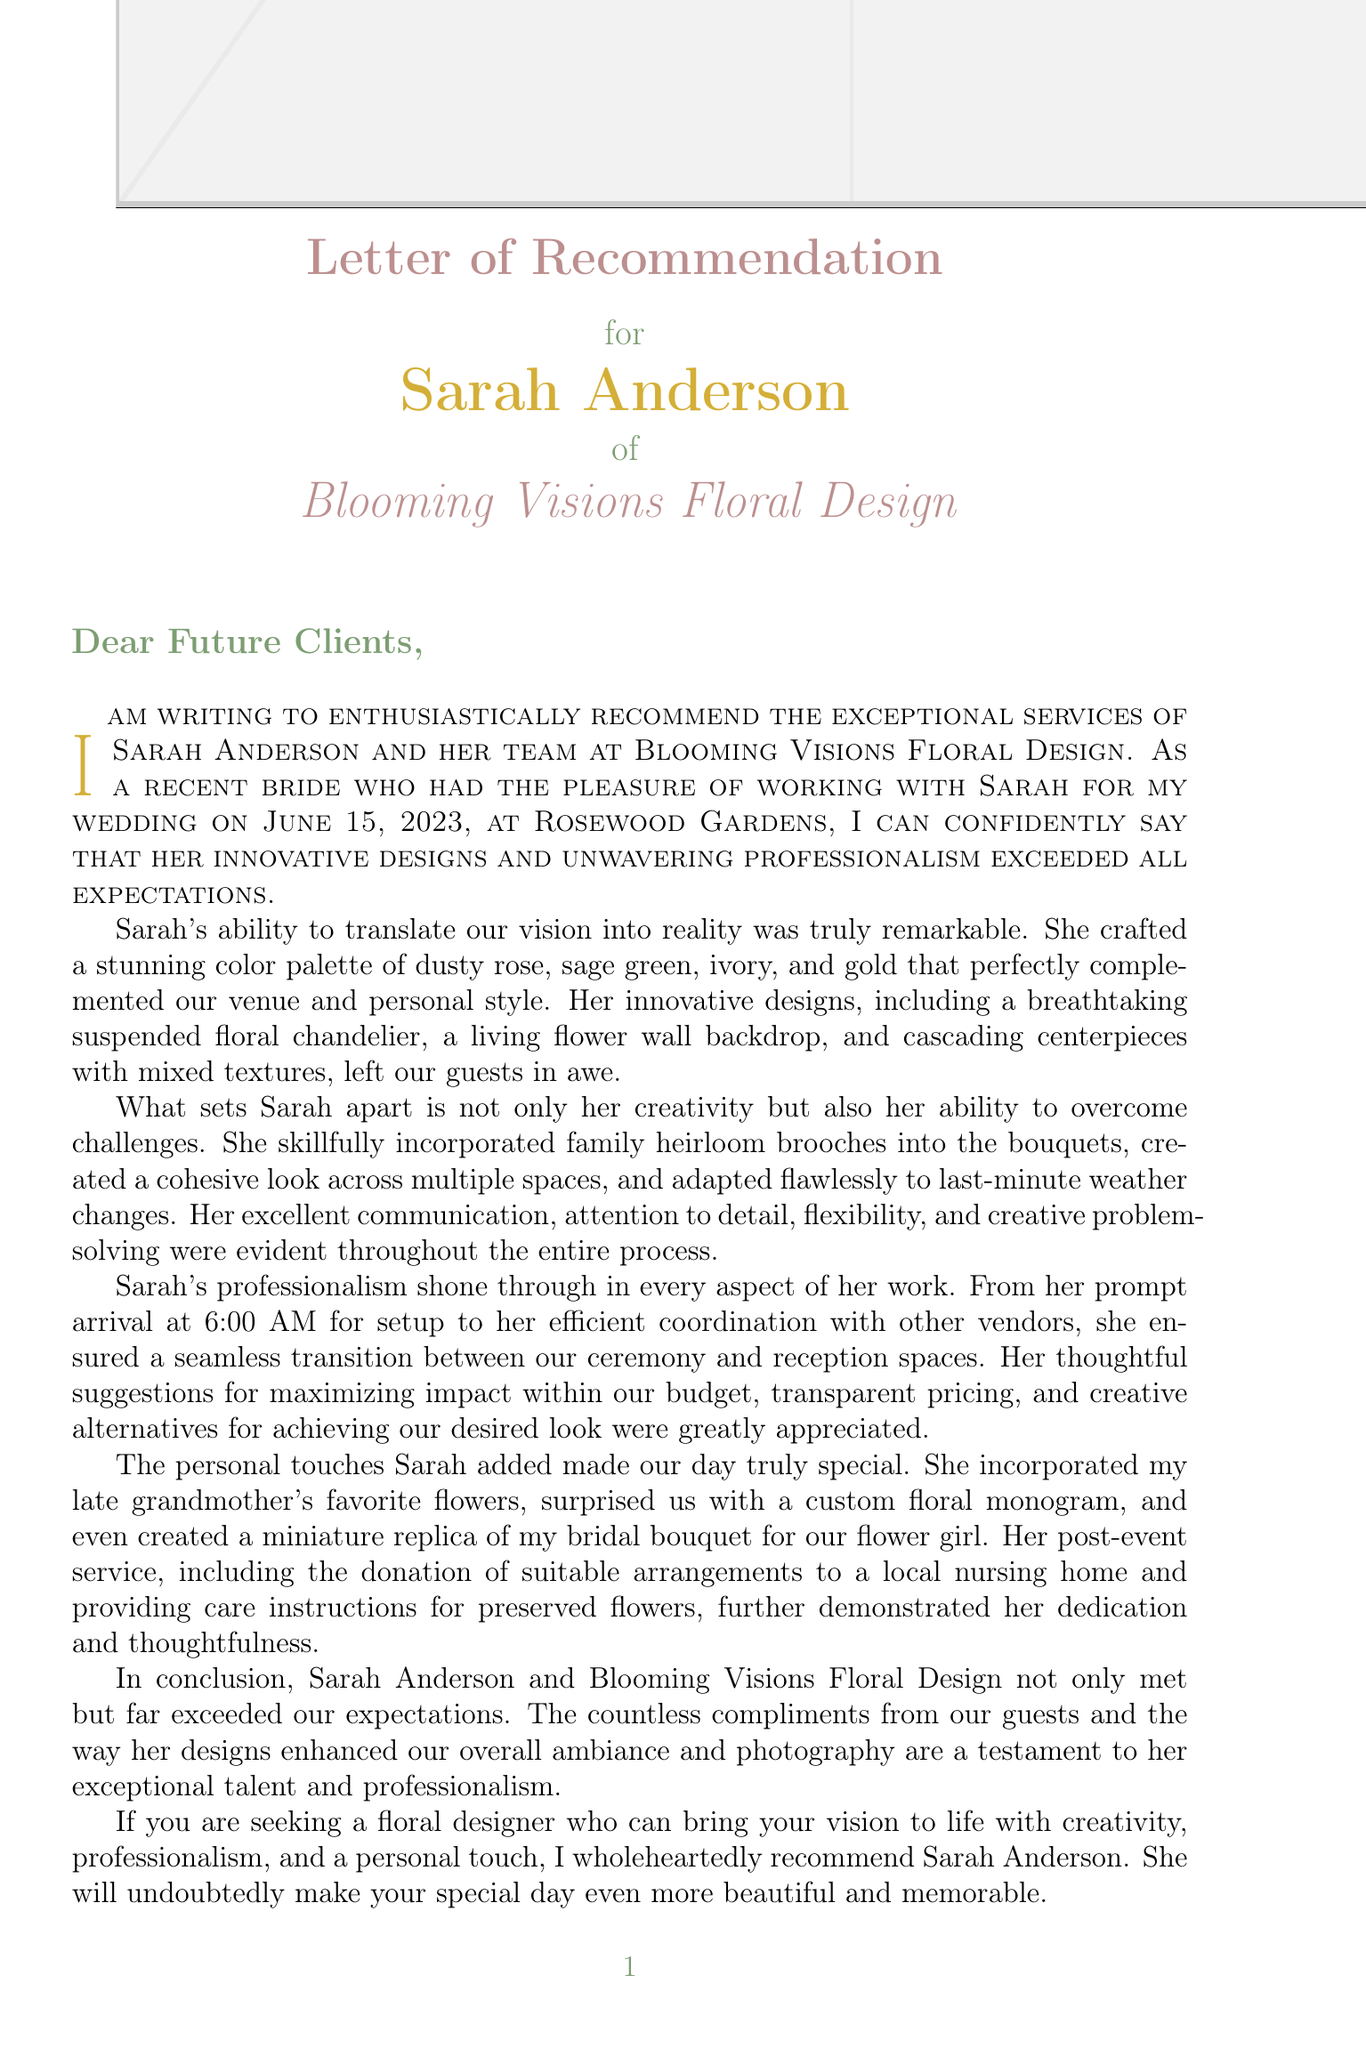What is the client's name? The client's name is explicitly stated in the document as the person writing the letter.
Answer: Emily Thompson What is the wedding date? The document mentions the specific date of the client's wedding.
Answer: June 15, 2023 What venue was used for the wedding? The venue is clearly identified as the location of the wedding.
Answer: Rosewood Gardens List one innovative design mentioned in the letter. The letter highlights specific innovative designs created by the floral designer.
Answer: suspended floral chandelier What were two of the color palette colors? The document presents a list of colors used in the wedding's color palette.
Answer: dusty rose, sage green What challenging aspect was noted regarding family heirlooms? The letter describes a specific challenge related to incorporating family items into the floral designs.
Answer: incorporating family heirloom brooches into bouquets What time did the setup begin? The document specifies the time that the floral designer arrived for setup on the wedding day.
Answer: 6:00 AM What personal touch involved the bride's grandmother? The letter mentions a specific personal touch that included a family member's favorite flowers.
Answer: incorporating bride's late grandmother's favorite flowers How did the post-event service demonstrate thoughtfulness? The document details a specific action taken after the event that showcased the floral designer's thoughtfulness.
Answer: donation of suitable arrangements to local nursing home 